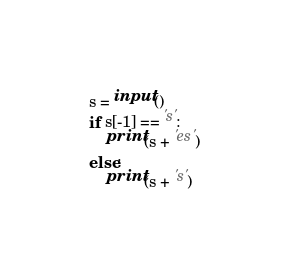Convert code to text. <code><loc_0><loc_0><loc_500><loc_500><_Python_>s = input()
if s[-1] == 's':
    print(s + 'es')
else:
    print(s + 's')
</code> 